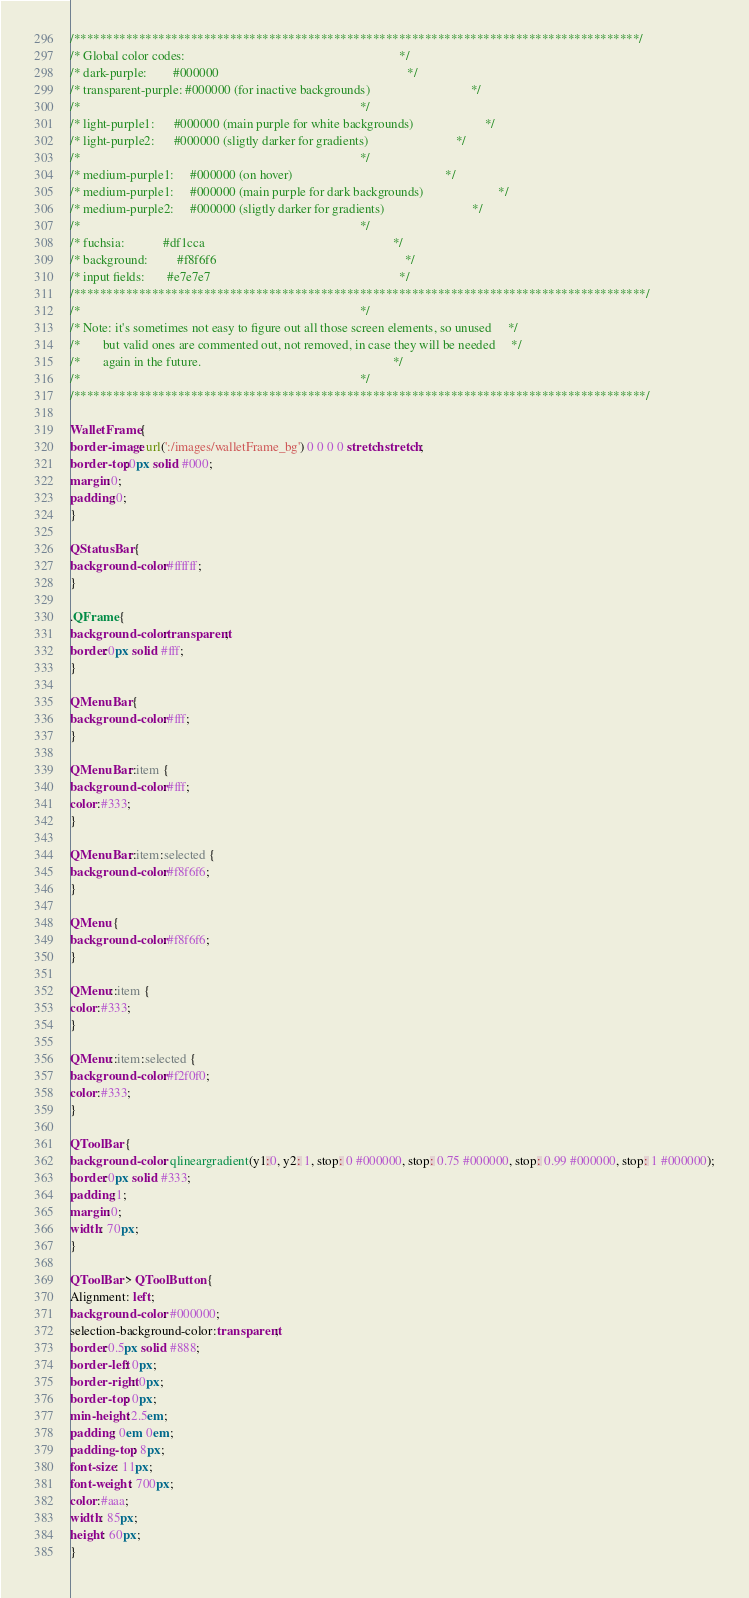<code> <loc_0><loc_0><loc_500><loc_500><_CSS_>/***************************************************************************************/
/* Global color codes:                                                                  */
/* dark-purple:        #000000                                                          */
/* transparent-purple: #000000 (for inactive backgrounds)                               */
/*                                                                                      */
/* light-purple1:      #000000 (main purple for white backgrounds)                      */
/* light-purple2:      #000000 (sligtly darker for gradients)                           */
/*                                                                                      */
/* medium-purple1:     #000000 (on hover)                                               */
/* medium-purple1:     #000000 (main purple for dark backgrounds)                       */
/* medium-purple2:     #000000 (sligtly darker for gradients)                           */
/*                                                                                      */
/* fuchsia:            #df1cca                                                          */
/* background:         #f8f6f6                                                          */
/* input fields:       #e7e7e7                                                          */
/****************************************************************************************/
/*                                                                                      */
/* Note: it's sometimes not easy to figure out all those screen elements, so unused     */
/*       but valid ones are commented out, not removed, in case they will be needed     */
/*       again in the future.                                                           */
/*                                                                                      */
/****************************************************************************************/

WalletFrame {
border-image: url(':/images/walletFrame_bg') 0 0 0 0 stretch stretch;
border-top:0px solid #000;
margin:0;
padding:0;
}

QStatusBar {
background-color:#ffffff;
}

.QFrame {
background-color:transparent;
border:0px solid #fff;
}

QMenuBar {
background-color:#fff;
}

QMenuBar::item {
background-color:#fff;
color:#333;
}

QMenuBar::item:selected {
background-color:#f8f6f6;
}

QMenu {
background-color:#f8f6f6;
}

QMenu::item {
color:#333;
}

QMenu::item:selected {
background-color:#f2f0f0;
color:#333;
}

QToolBar {
background-color: qlineargradient(y1:0, y2: 1, stop: 0 #000000, stop: 0.75 #000000, stop: 0.99 #000000, stop: 1 #000000);
border:0px solid #333;
padding:1;
margin:0;
width: 70px;
}

QToolBar > QToolButton {
Alignment: left;
background-color: #000000;
selection-background-color:transparent;
border:0.5px solid #888;
border-left: 0px;
border-right: 0px;
border-top: 0px;
min-height:2.5em;
padding: 0em 0em;
padding-top: 8px;
font-size: 11px;
font-weight: 700px;
color:#aaa;
width: 85px;
height: 60px;
}
</code> 